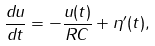<formula> <loc_0><loc_0><loc_500><loc_500>\frac { d u } { d t } = - \frac { u ( t ) } { R C } + \eta ^ { \prime } ( t ) ,</formula> 